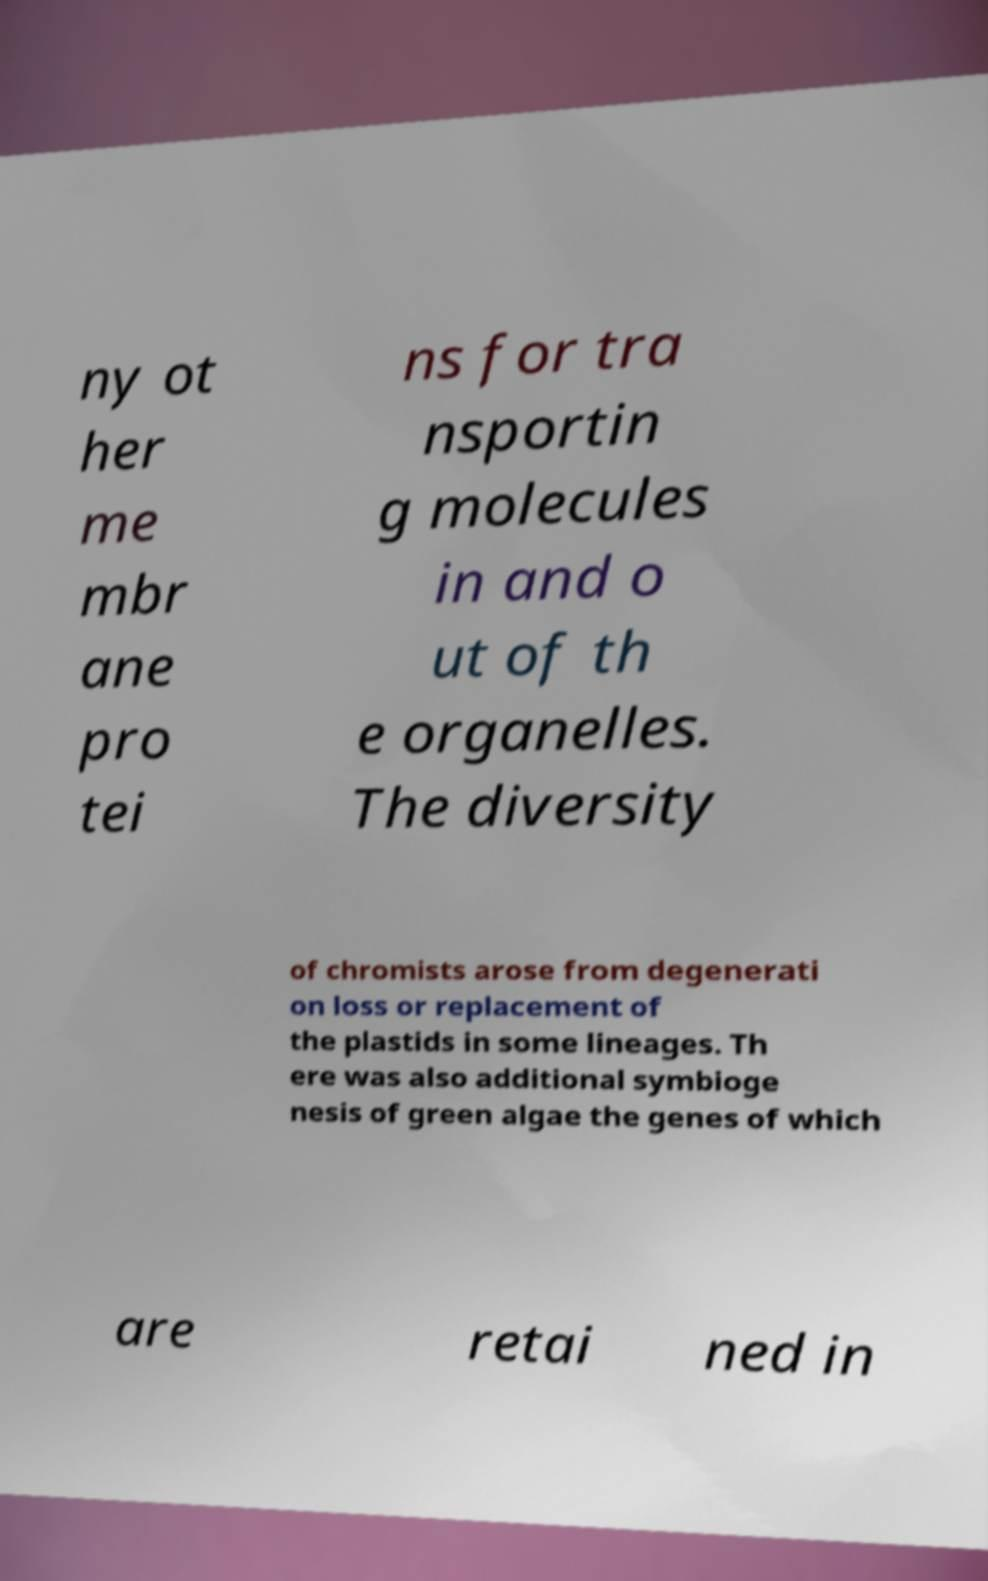For documentation purposes, I need the text within this image transcribed. Could you provide that? ny ot her me mbr ane pro tei ns for tra nsportin g molecules in and o ut of th e organelles. The diversity of chromists arose from degenerati on loss or replacement of the plastids in some lineages. Th ere was also additional symbioge nesis of green algae the genes of which are retai ned in 